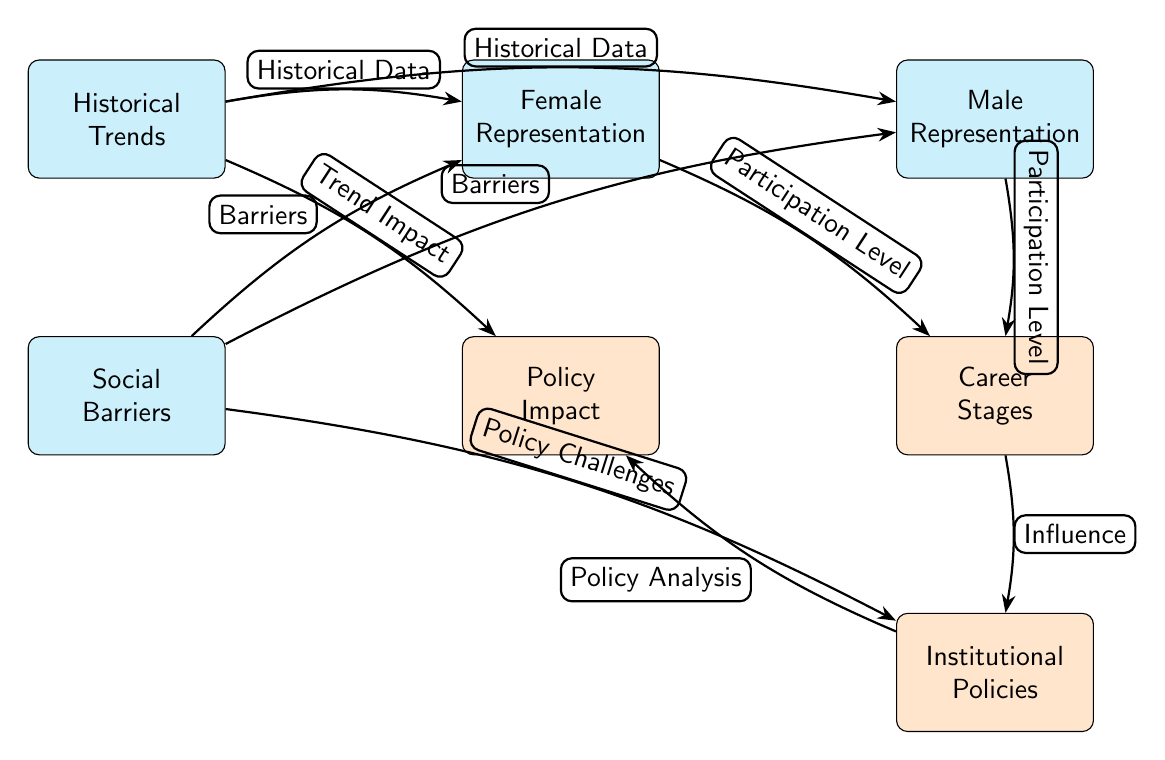What are the two main types of representation shown in the diagram? The diagram identifies two main types of representation: Female Representation and Male Representation. These nodes are distinctly labeled at the top of the diagram.
Answer: Female Representation, Male Representation What is the relationship between Female Representation and Career Stages? The diagram indicates that the relationship is characterized as "Participation Level," which is an edge connecting Female Representation to Career Stages, showing that participation levels influence career stages.
Answer: Participation Level How many nodes exist in this diagram? By counting each unique node represented in the diagram, there are a total of seven nodes connected by edges.
Answer: Seven What influences Institutional Policies according to the diagram? The diagram illustrates that the influence on Institutional Policies comes from Career Stages, which connects to Institutional Policies through the labeled edge "Influence."
Answer: Career Stages What challenges are identified in relation to Social Barriers? The diagram states that Social Barriers challenge both Female Representation and Male Representation, indicating that these barriers create obstacles for both genders in the field.
Answer: Barriers How does Historical Trends affect Male Representation? The edge labeled "Historical Data" connects Historical Trends to Male Representation, indicating that historical trends have a direct impact on the representation of males in the astronomical science field.
Answer: Historical Data What does the node "Policy Impact" indicate in relation to Career Stages? In the diagram, Policy Impact is connected to Institutional Policies by "Policy Analysis," which suggests that policies derived from the analysis impact career stages in the field.
Answer: Policy Analysis What is the edge label that connects Social Barriers to Institutional Policies? The edge from Social Barriers to Institutional Policies is labeled "Policy Challenges," indicating that the barriers present pose challenges for the implementation of effective policies.
Answer: Policy Challenges 